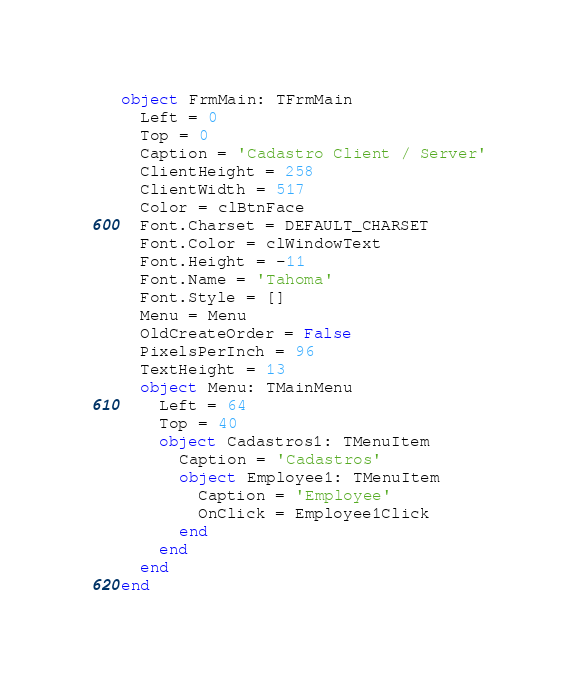<code> <loc_0><loc_0><loc_500><loc_500><_Pascal_>object FrmMain: TFrmMain
  Left = 0
  Top = 0
  Caption = 'Cadastro Client / Server'
  ClientHeight = 258
  ClientWidth = 517
  Color = clBtnFace
  Font.Charset = DEFAULT_CHARSET
  Font.Color = clWindowText
  Font.Height = -11
  Font.Name = 'Tahoma'
  Font.Style = []
  Menu = Menu
  OldCreateOrder = False
  PixelsPerInch = 96
  TextHeight = 13
  object Menu: TMainMenu
    Left = 64
    Top = 40
    object Cadastros1: TMenuItem
      Caption = 'Cadastros'
      object Employee1: TMenuItem
        Caption = 'Employee'
        OnClick = Employee1Click
      end
    end
  end
end
</code> 